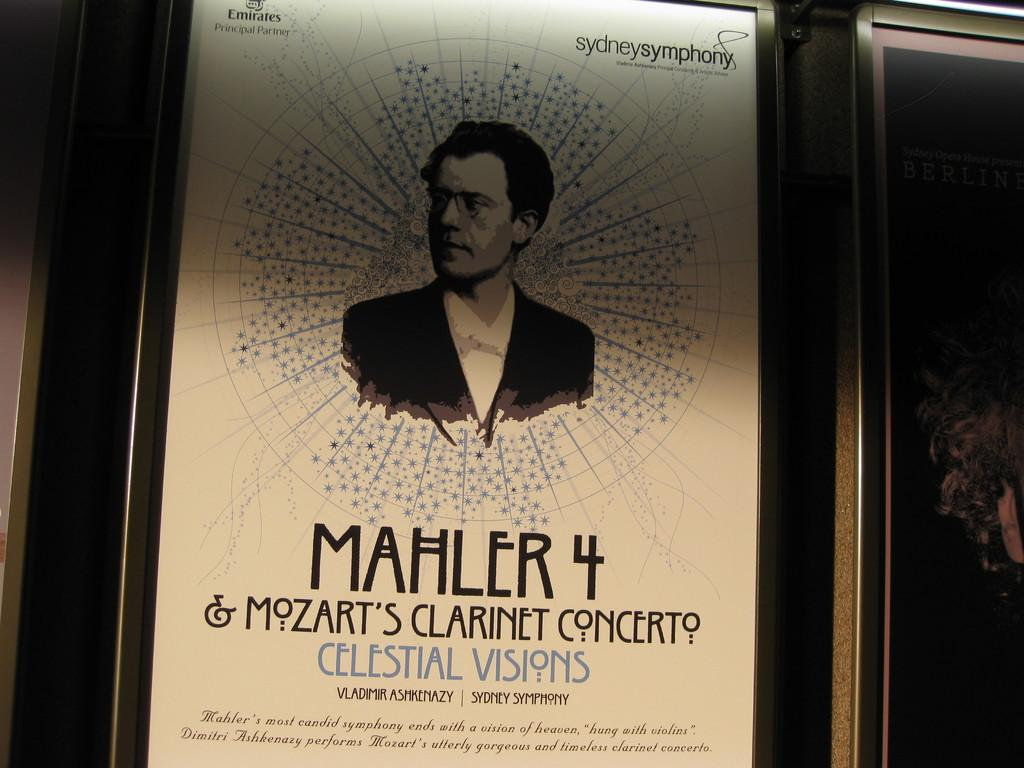<image>
Offer a succinct explanation of the picture presented. A mozart clarinet concert poster with Mahler 4 and a picture of a man on it. 